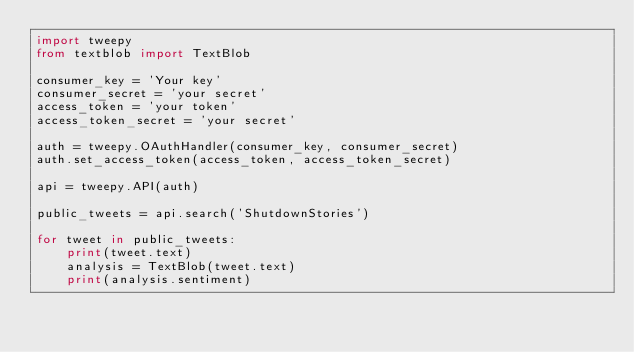<code> <loc_0><loc_0><loc_500><loc_500><_Python_>import tweepy
from textblob import TextBlob

consumer_key = 'Your key'
consumer_secret = 'your secret'
access_token = 'your token'
access_token_secret = 'your secret'

auth = tweepy.OAuthHandler(consumer_key, consumer_secret)
auth.set_access_token(access_token, access_token_secret)

api = tweepy.API(auth)

public_tweets = api.search('ShutdownStories')

for tweet in public_tweets:
    print(tweet.text)
    analysis = TextBlob(tweet.text)
    print(analysis.sentiment)</code> 